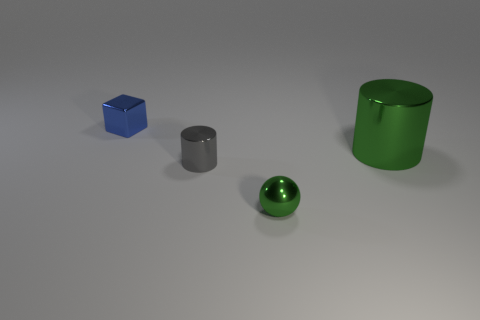How would you categorize the materials of the objects based on how they interact with light? The objects in the image appear to be made of different materials, each interacting distinctly with light. The green sphere and the silver cylinder have reflective surfaces indicating a possible metallic or polished nature. In contrast, the blue cube and the green cylinder have a matte finish, suggesting a less reflective material, possibly plastic or painted metal. 